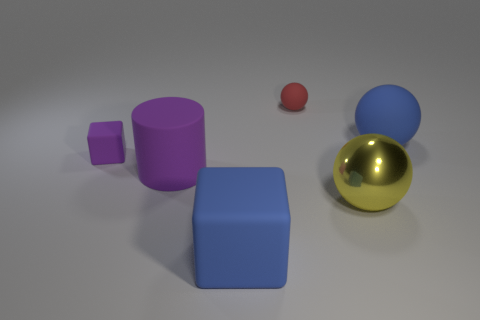Are there any big rubber cylinders of the same color as the small matte cube?
Provide a short and direct response. Yes. How many small objects are purple matte blocks or purple rubber cylinders?
Your response must be concise. 1. There is a object that is left of the red matte thing and in front of the big rubber cylinder; what is its size?
Ensure brevity in your answer.  Large. There is a yellow thing; what number of big rubber objects are behind it?
Give a very brief answer. 2. There is a thing that is both behind the matte cylinder and in front of the blue rubber sphere; what is its shape?
Provide a succinct answer. Cube. What number of cubes are yellow shiny objects or tiny things?
Provide a succinct answer. 1. What is the size of the thing that is the same color as the large cube?
Make the answer very short. Large. Is the number of purple rubber cylinders in front of the large cylinder less than the number of blue metal spheres?
Offer a terse response. No. There is a ball that is both on the right side of the small matte ball and behind the big metallic object; what is its color?
Offer a very short reply. Blue. What number of other things are there of the same shape as the tiny purple object?
Your answer should be compact. 1. 